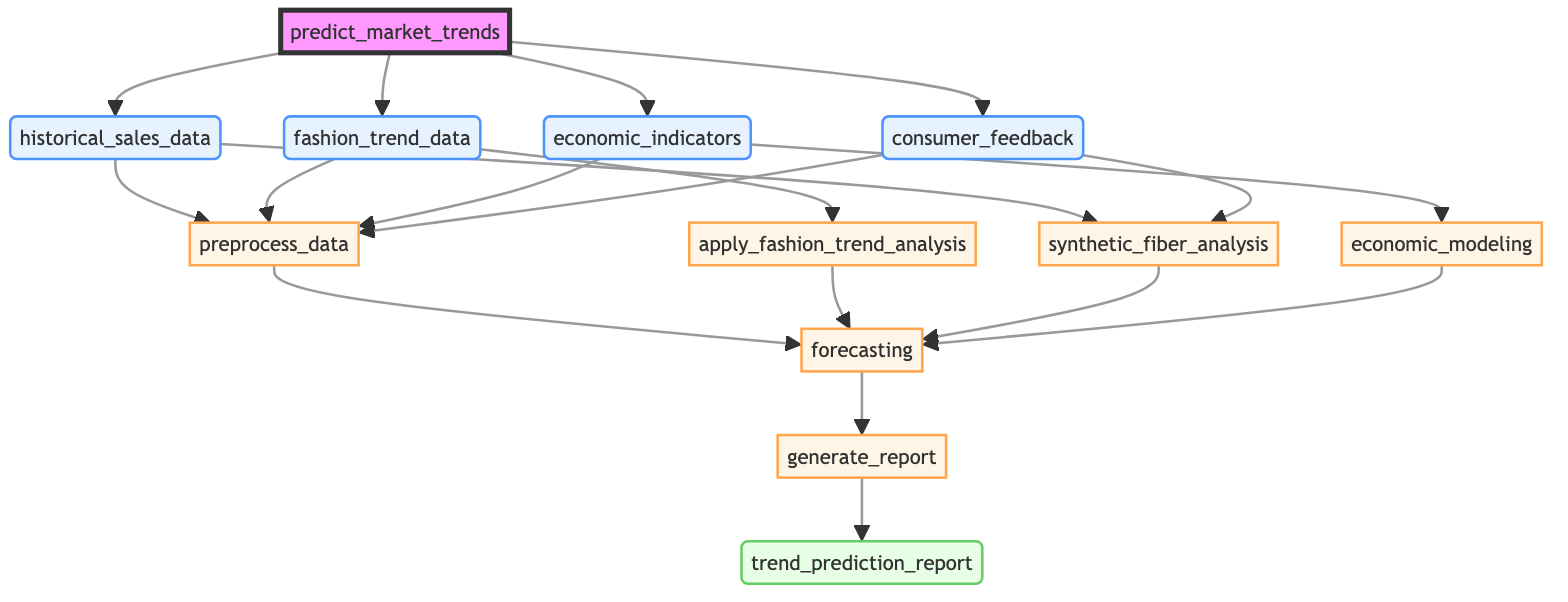What is the output of the function predict_market_trends? The diagram indicates that the output of the function is a trend prediction report, generated after all process steps have been completed.
Answer: trend_prediction_report How many input parameters does the function have? The diagram shows four input parameters that feed into the function: historical sales data, fashion trend data, economic indicators, and consumer feedback.
Answer: 4 What follows after preprocess_data? Following the preprocess_data step, the diagram indicates that the next steps depend on various inputs: apply fashion trend analysis, synthetic fiber analysis, and economic modeling occur in parallel.
Answer: apply_fashion_trend_analysis, synthetic_fiber_analysis, economic_modeling Which step analyzes recent fashion trends? Referring to the diagram, the process labeled apply fashion trend analysis is specifically designated for analyzing recent fashion trends using relevant datasets and social media sentiment.
Answer: apply_fashion_trend_analysis What is the first step in the process? In the flowchart, the first step in the sequence after the inputs is preprocess_data, which cleans and standardizes the input data.
Answer: preprocess_data Which steps depend on both historical_sales_data and consumer_feedback? Looking through the diagram, both the synthetic fiber analysis and the forecasting process depend on historical sales data and consumer feedback as their underlying components.
Answer: synthetic_fiber_analysis, forecasting How many process steps are shown in the diagram? The diagram clearly highlights six identifiable process steps that are executed as part of the function’s workflow from input to output.
Answer: 6 What does the economic_modeling step incorporate? The economic_modeling step incorporates economic indicators to adjust market predictions according to existing market conditions.
Answer: economic indicators Which step generates a detailed report? The diagram specifies that the generate_report step is responsible for producing the detailed report that includes visualizations of market trend predictions.
Answer: generate_report 